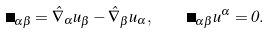<formula> <loc_0><loc_0><loc_500><loc_500>\Omega _ { \alpha \beta } = \hat { \nabla } _ { \alpha } u _ { \beta } - \hat { \nabla } _ { \beta } u _ { \alpha } , \quad \Omega _ { \alpha \beta } u ^ { \alpha } = 0 .</formula> 